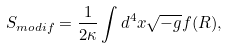<formula> <loc_0><loc_0><loc_500><loc_500>S _ { m o d i f } = \frac { 1 } { 2 \kappa } \int d ^ { 4 } x \sqrt { - g } f ( R ) ,</formula> 